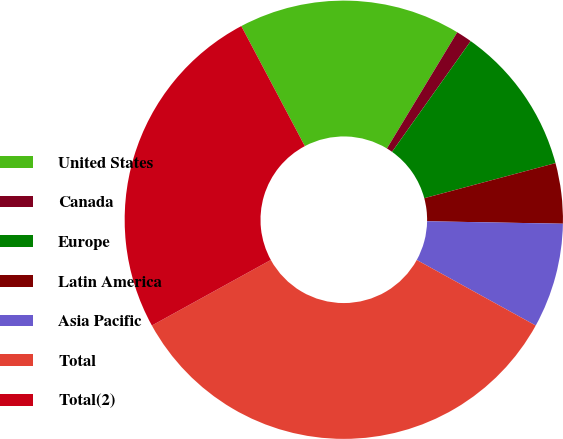Convert chart to OTSL. <chart><loc_0><loc_0><loc_500><loc_500><pie_chart><fcel>United States<fcel>Canada<fcel>Europe<fcel>Latin America<fcel>Asia Pacific<fcel>Total<fcel>Total(2)<nl><fcel>16.41%<fcel>1.17%<fcel>11.01%<fcel>4.45%<fcel>7.73%<fcel>33.97%<fcel>25.27%<nl></chart> 